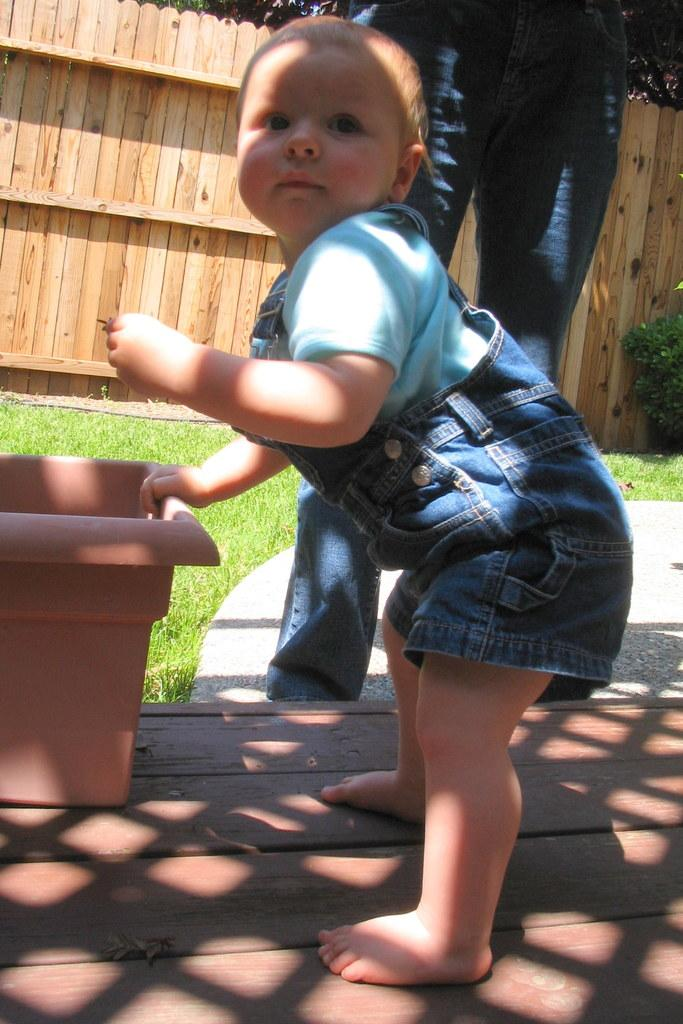What is the person in the image doing? The person is standing on the road. What is the child in the image doing? The child is standing on a wooden surface and holding a pot. What can be seen in the background of the image? There is a wooden grill in the background. What type of tramp is visible in the image? There is no tramp present in the image. How many elbows can be seen in the image? The number of elbows cannot be determined from the image, as it only shows a person standing on the road and a child holding a pot. 